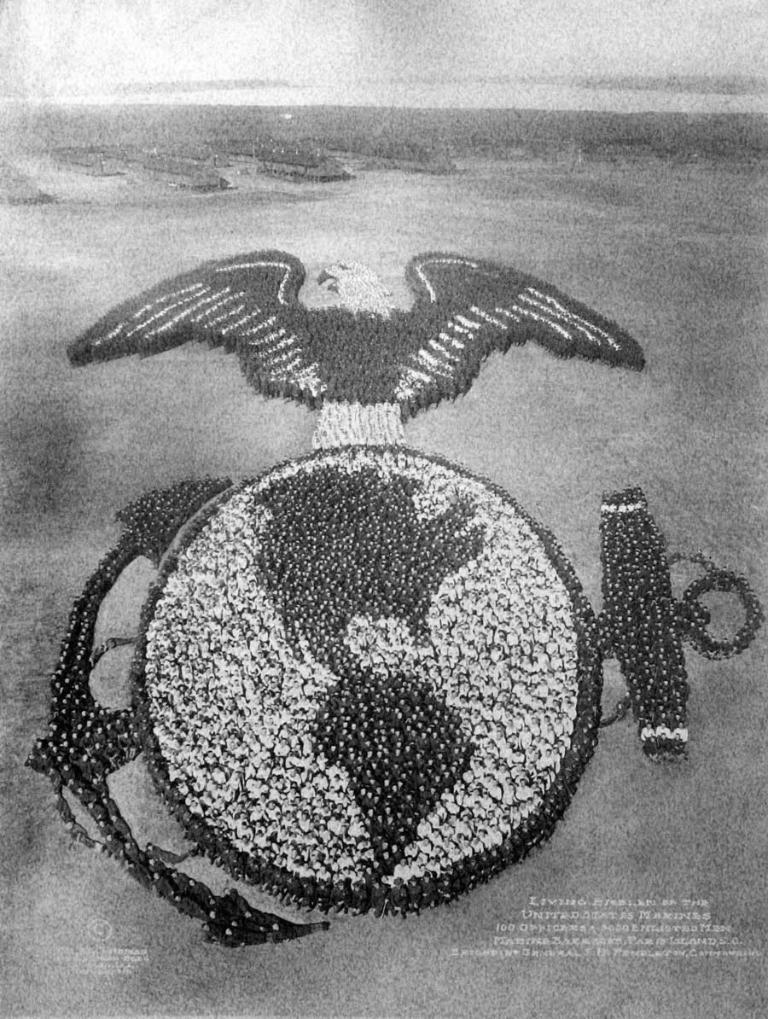What is the color scheme of the image? The image is black and white. What can be seen in the image? There are people in the image. Where are the people located in the image? The people are standing on the ground. What are the people doing in the image? The people are forming a logo. What type of leather is being used to create the advertisement in the image? There is no leather or advertisement present in the image; it features people forming a logo in a black and white setting. 